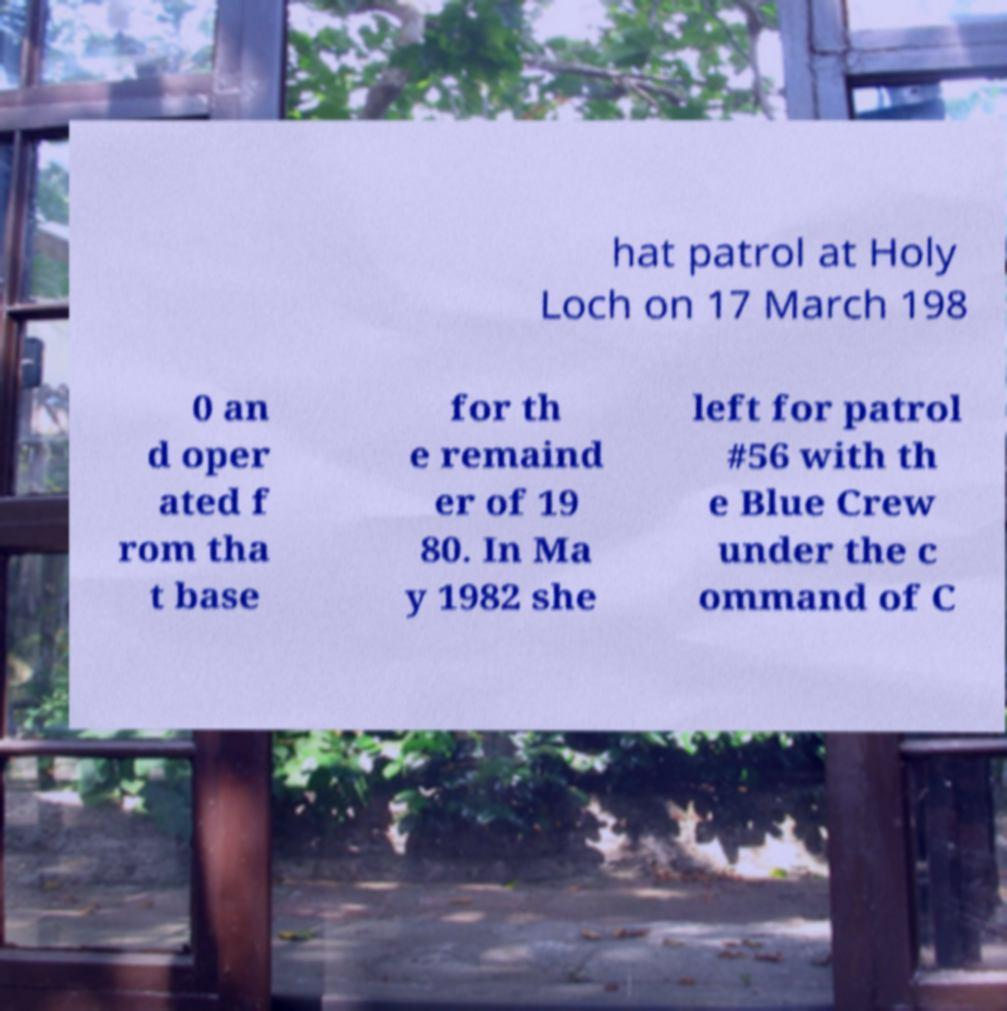For documentation purposes, I need the text within this image transcribed. Could you provide that? hat patrol at Holy Loch on 17 March 198 0 an d oper ated f rom tha t base for th e remaind er of 19 80. In Ma y 1982 she left for patrol #56 with th e Blue Crew under the c ommand of C 